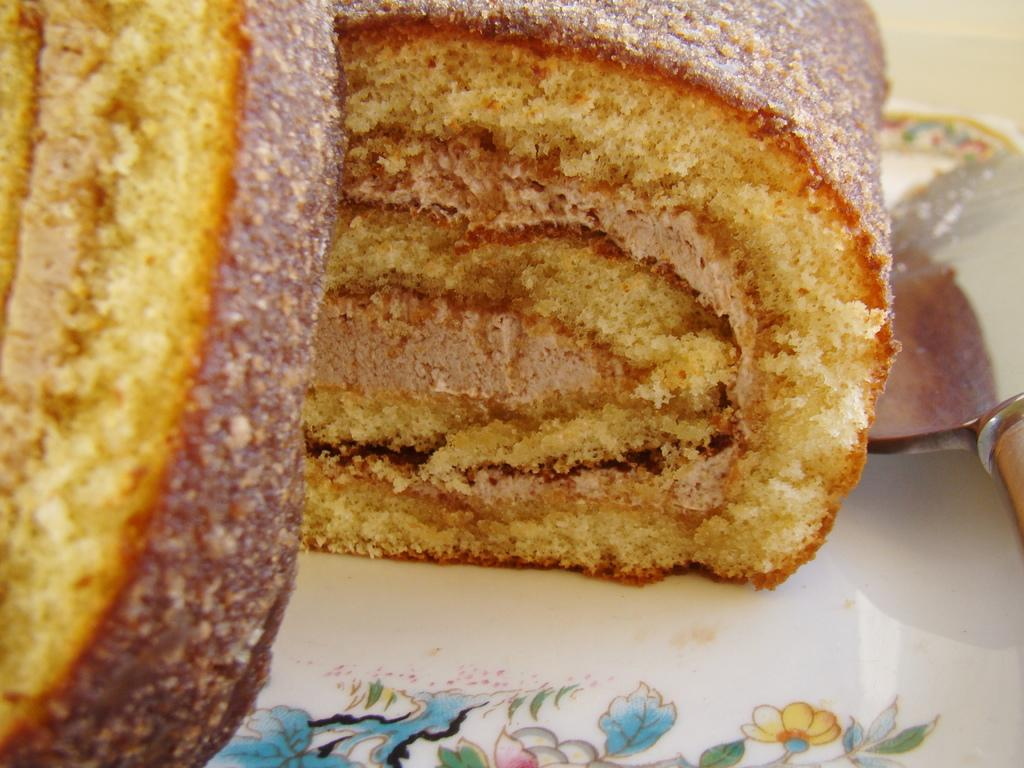What types of food items can be seen in the image? There are food items in the image, but their specific types cannot be determined without more information. What utensil is placed in a plate in the image? There is a knife placed in a plate in the image. How is the food being distributed in the image? There is no information about the distribution of food in the image; it only shows food items and a knife placed in a plate. 